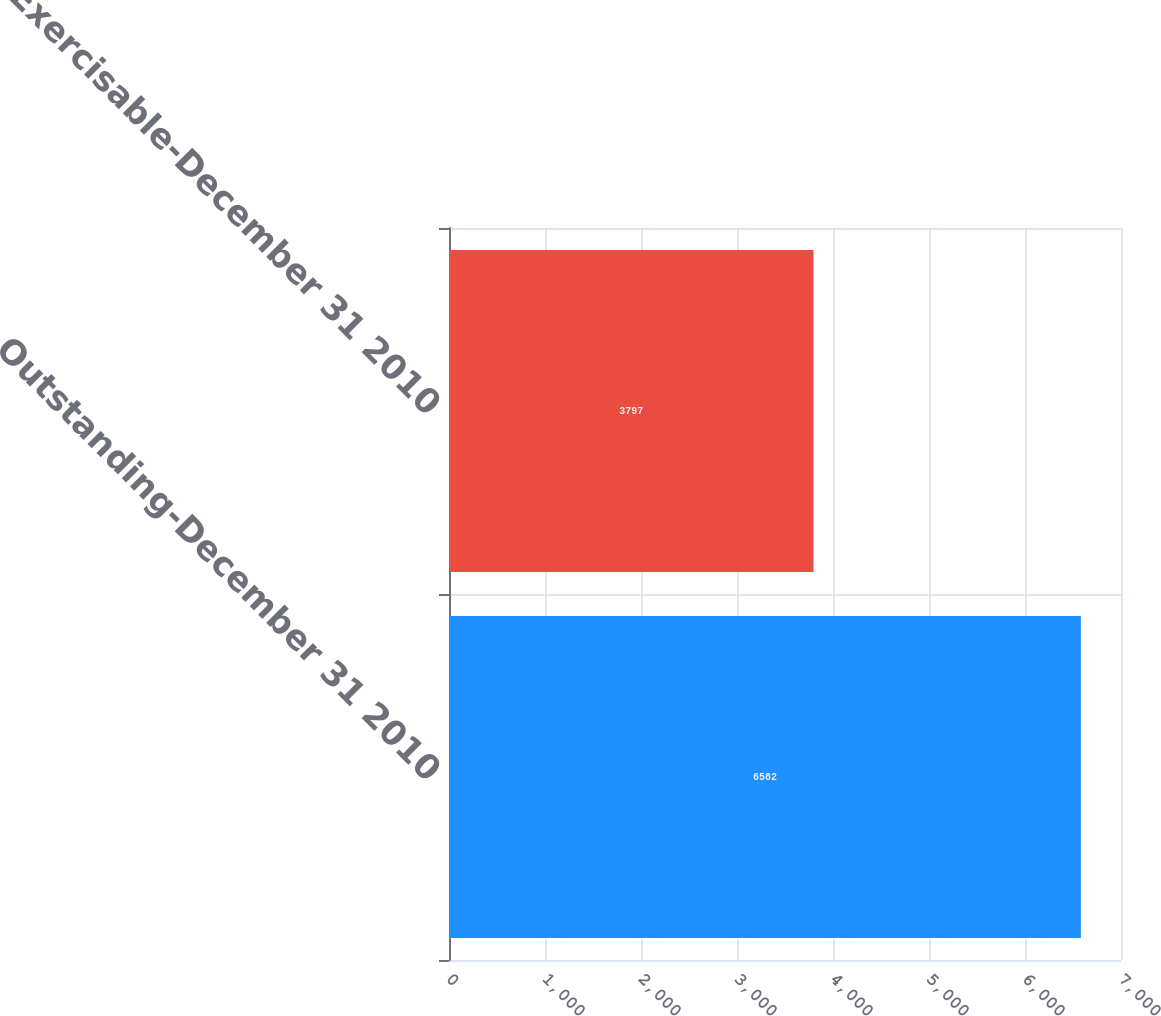Convert chart to OTSL. <chart><loc_0><loc_0><loc_500><loc_500><bar_chart><fcel>Outstanding-December 31 2010<fcel>Exercisable-December 31 2010<nl><fcel>6582<fcel>3797<nl></chart> 